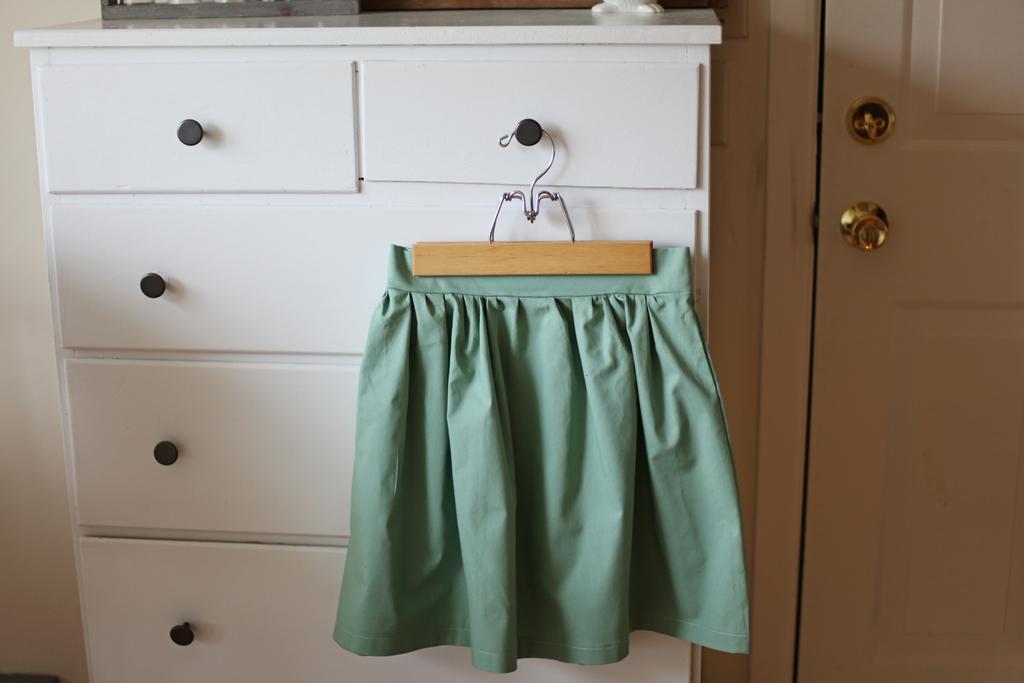Can you describe this image briefly? Here we can see a cloth hanging to a cupboard rack and we can see a door and this is a wall. 